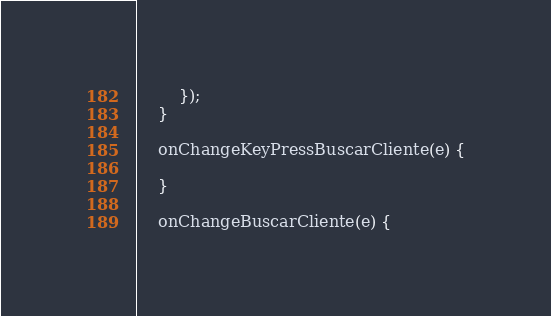<code> <loc_0><loc_0><loc_500><loc_500><_JavaScript_>        });
    }

    onChangeKeyPressBuscarCliente(e) {
        
    }

    onChangeBuscarCliente(e) {</code> 